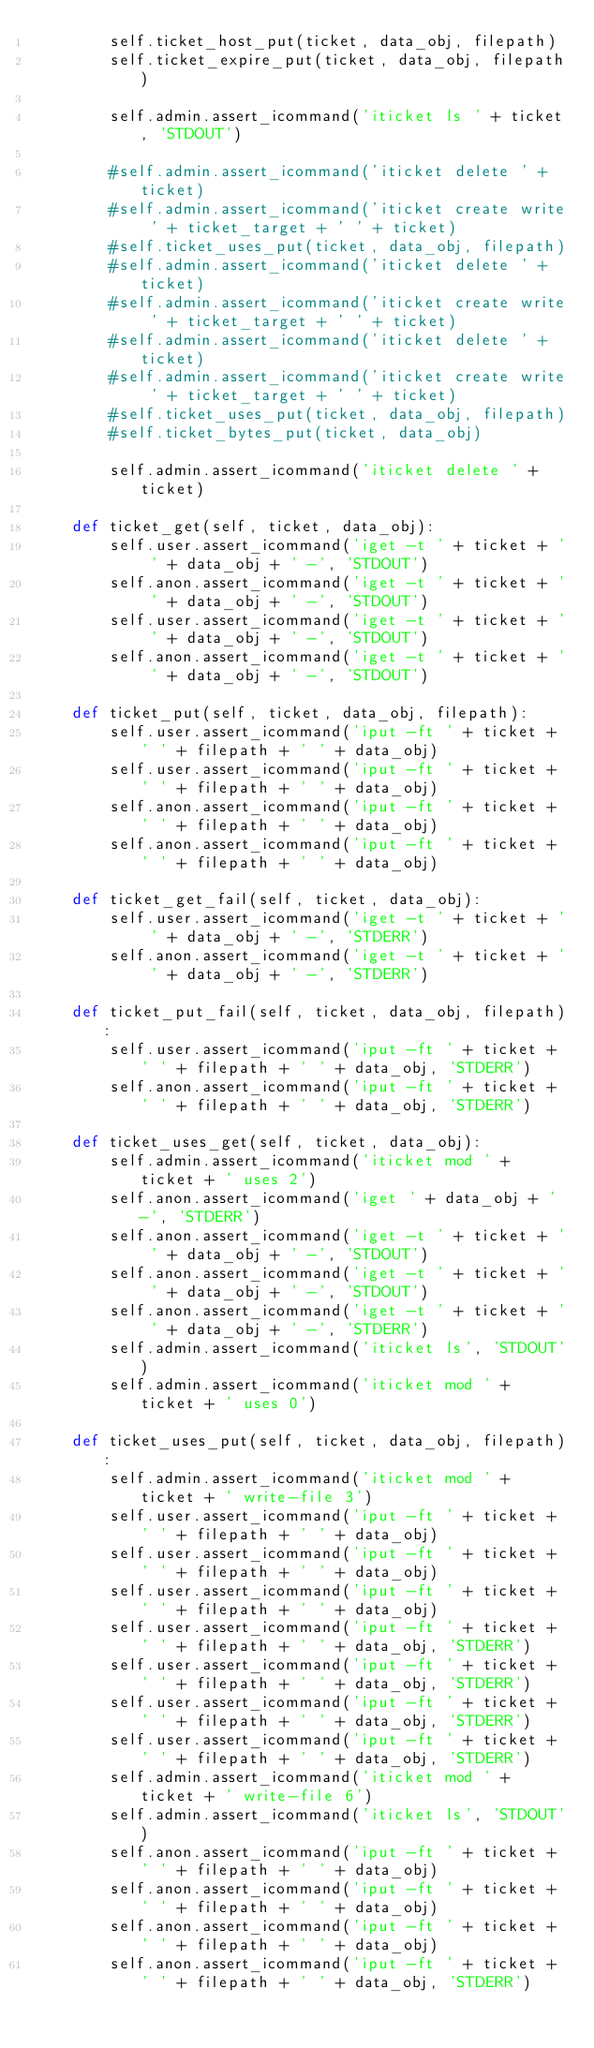<code> <loc_0><loc_0><loc_500><loc_500><_Python_>        self.ticket_host_put(ticket, data_obj, filepath)
        self.ticket_expire_put(ticket, data_obj, filepath)

        self.admin.assert_icommand('iticket ls ' + ticket, 'STDOUT')

        #self.admin.assert_icommand('iticket delete ' + ticket)
        #self.admin.assert_icommand('iticket create write ' + ticket_target + ' ' + ticket)
        #self.ticket_uses_put(ticket, data_obj, filepath)
        #self.admin.assert_icommand('iticket delete ' + ticket)
        #self.admin.assert_icommand('iticket create write ' + ticket_target + ' ' + ticket)
        #self.admin.assert_icommand('iticket delete ' + ticket)
        #self.admin.assert_icommand('iticket create write ' + ticket_target + ' ' + ticket)
        #self.ticket_uses_put(ticket, data_obj, filepath)
        #self.ticket_bytes_put(ticket, data_obj)

        self.admin.assert_icommand('iticket delete ' + ticket)

    def ticket_get(self, ticket, data_obj):
        self.user.assert_icommand('iget -t ' + ticket + ' ' + data_obj + ' -', 'STDOUT')
        self.anon.assert_icommand('iget -t ' + ticket + ' ' + data_obj + ' -', 'STDOUT')
        self.user.assert_icommand('iget -t ' + ticket + ' ' + data_obj + ' -', 'STDOUT')
        self.anon.assert_icommand('iget -t ' + ticket + ' ' + data_obj + ' -', 'STDOUT')

    def ticket_put(self, ticket, data_obj, filepath):
        self.user.assert_icommand('iput -ft ' + ticket + ' ' + filepath + ' ' + data_obj)
        self.user.assert_icommand('iput -ft ' + ticket + ' ' + filepath + ' ' + data_obj)
        self.anon.assert_icommand('iput -ft ' + ticket + ' ' + filepath + ' ' + data_obj)
        self.anon.assert_icommand('iput -ft ' + ticket + ' ' + filepath + ' ' + data_obj)

    def ticket_get_fail(self, ticket, data_obj):
        self.user.assert_icommand('iget -t ' + ticket + ' ' + data_obj + ' -', 'STDERR')
        self.anon.assert_icommand('iget -t ' + ticket + ' ' + data_obj + ' -', 'STDERR')

    def ticket_put_fail(self, ticket, data_obj, filepath):
        self.user.assert_icommand('iput -ft ' + ticket + ' ' + filepath + ' ' + data_obj, 'STDERR')
        self.anon.assert_icommand('iput -ft ' + ticket + ' ' + filepath + ' ' + data_obj, 'STDERR')

    def ticket_uses_get(self, ticket, data_obj):
        self.admin.assert_icommand('iticket mod ' + ticket + ' uses 2')
        self.anon.assert_icommand('iget ' + data_obj + ' -', 'STDERR')
        self.anon.assert_icommand('iget -t ' + ticket + ' ' + data_obj + ' -', 'STDOUT')
        self.anon.assert_icommand('iget -t ' + ticket + ' ' + data_obj + ' -', 'STDOUT')
        self.anon.assert_icommand('iget -t ' + ticket + ' ' + data_obj + ' -', 'STDERR')
        self.admin.assert_icommand('iticket ls', 'STDOUT')
        self.admin.assert_icommand('iticket mod ' + ticket + ' uses 0')

    def ticket_uses_put(self, ticket, data_obj, filepath):
        self.admin.assert_icommand('iticket mod ' + ticket + ' write-file 3')
        self.user.assert_icommand('iput -ft ' + ticket + ' ' + filepath + ' ' + data_obj)
        self.user.assert_icommand('iput -ft ' + ticket + ' ' + filepath + ' ' + data_obj)
        self.user.assert_icommand('iput -ft ' + ticket + ' ' + filepath + ' ' + data_obj)
        self.user.assert_icommand('iput -ft ' + ticket + ' ' + filepath + ' ' + data_obj, 'STDERR')
        self.user.assert_icommand('iput -ft ' + ticket + ' ' + filepath + ' ' + data_obj, 'STDERR')
        self.user.assert_icommand('iput -ft ' + ticket + ' ' + filepath + ' ' + data_obj, 'STDERR')
        self.user.assert_icommand('iput -ft ' + ticket + ' ' + filepath + ' ' + data_obj, 'STDERR')
        self.admin.assert_icommand('iticket mod ' + ticket + ' write-file 6')
        self.admin.assert_icommand('iticket ls', 'STDOUT')
        self.anon.assert_icommand('iput -ft ' + ticket + ' ' + filepath + ' ' + data_obj)
        self.anon.assert_icommand('iput -ft ' + ticket + ' ' + filepath + ' ' + data_obj)
        self.anon.assert_icommand('iput -ft ' + ticket + ' ' + filepath + ' ' + data_obj)
        self.anon.assert_icommand('iput -ft ' + ticket + ' ' + filepath + ' ' + data_obj, 'STDERR')</code> 